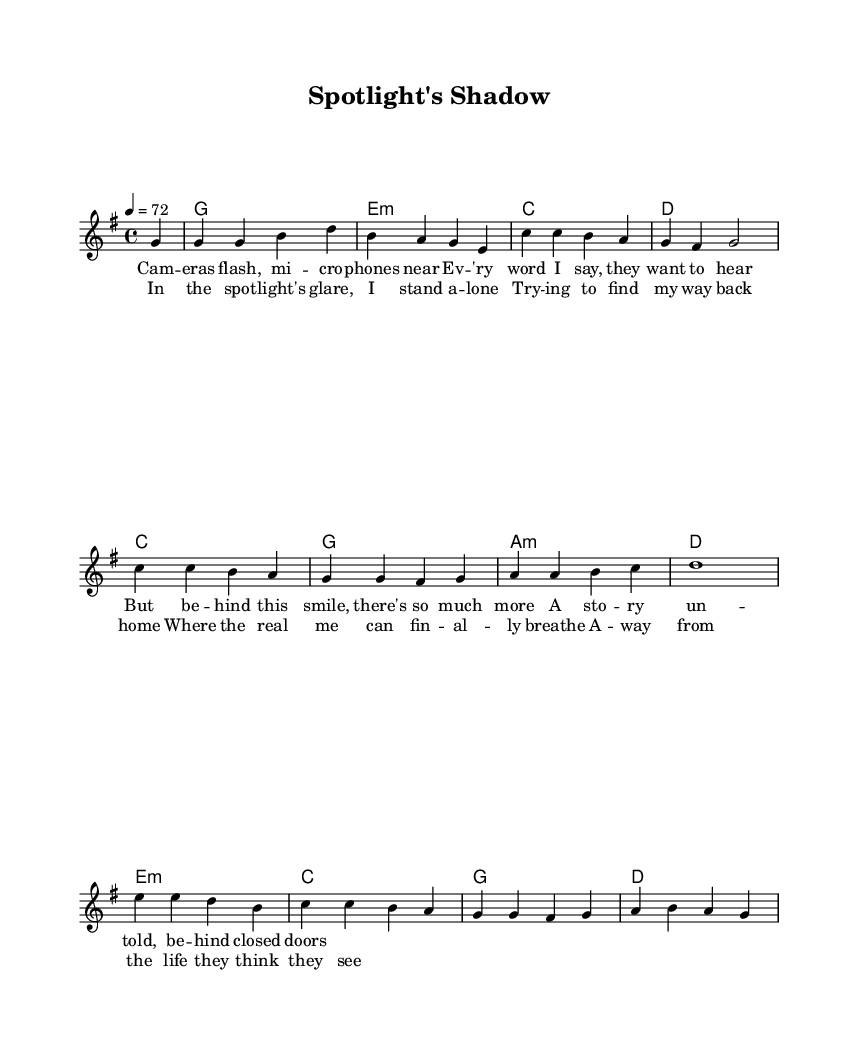What is the key signature of this music? The key signature is G major, which has one sharp (F#). This can be identified at the beginning of the sheet music just after the \key command.
Answer: G major What is the time signature of this music? The time signature is 4/4, which allows for four beats per measure. This is noted at the beginning of the score with the \time command.
Answer: 4/4 What is the tempo marking for this piece? The tempo marking is 72 beats per minute (bpm), indicated by the \tempo command at the beginning of the music.
Answer: 72 How many measures are in the chorus section? The chorus consists of 4 measures, which can be counted by identifying the musical sections and their lengths in the score. Each line in the chorus represents a measure.
Answer: 4 What is the primary theme reflected in the lyrics? The primary theme of the lyrics revolves around the pressures and emotions of being in the spotlight, highlighting the contrast between public perception and personal reality. This can be deduced by analyzing the text of the lyrics provided.
Answer: Pressure How often is the harmony of E minor used in the progression? The harmony of E minor appears twice in the chord progression, specifically noted in the harmonies section of the sheet music. Counting the occurrences will reveal the answer.
Answer: 2 What musical form does this ballad primarily resemble? This ballad primarily resembles a verse-chorus form where the verses tell a story, and the chorus emphasizes the main message or emotional impact. This can be inferred by looking at the structure of the lyrics and their arrangement in the score.
Answer: Verse-chorus 